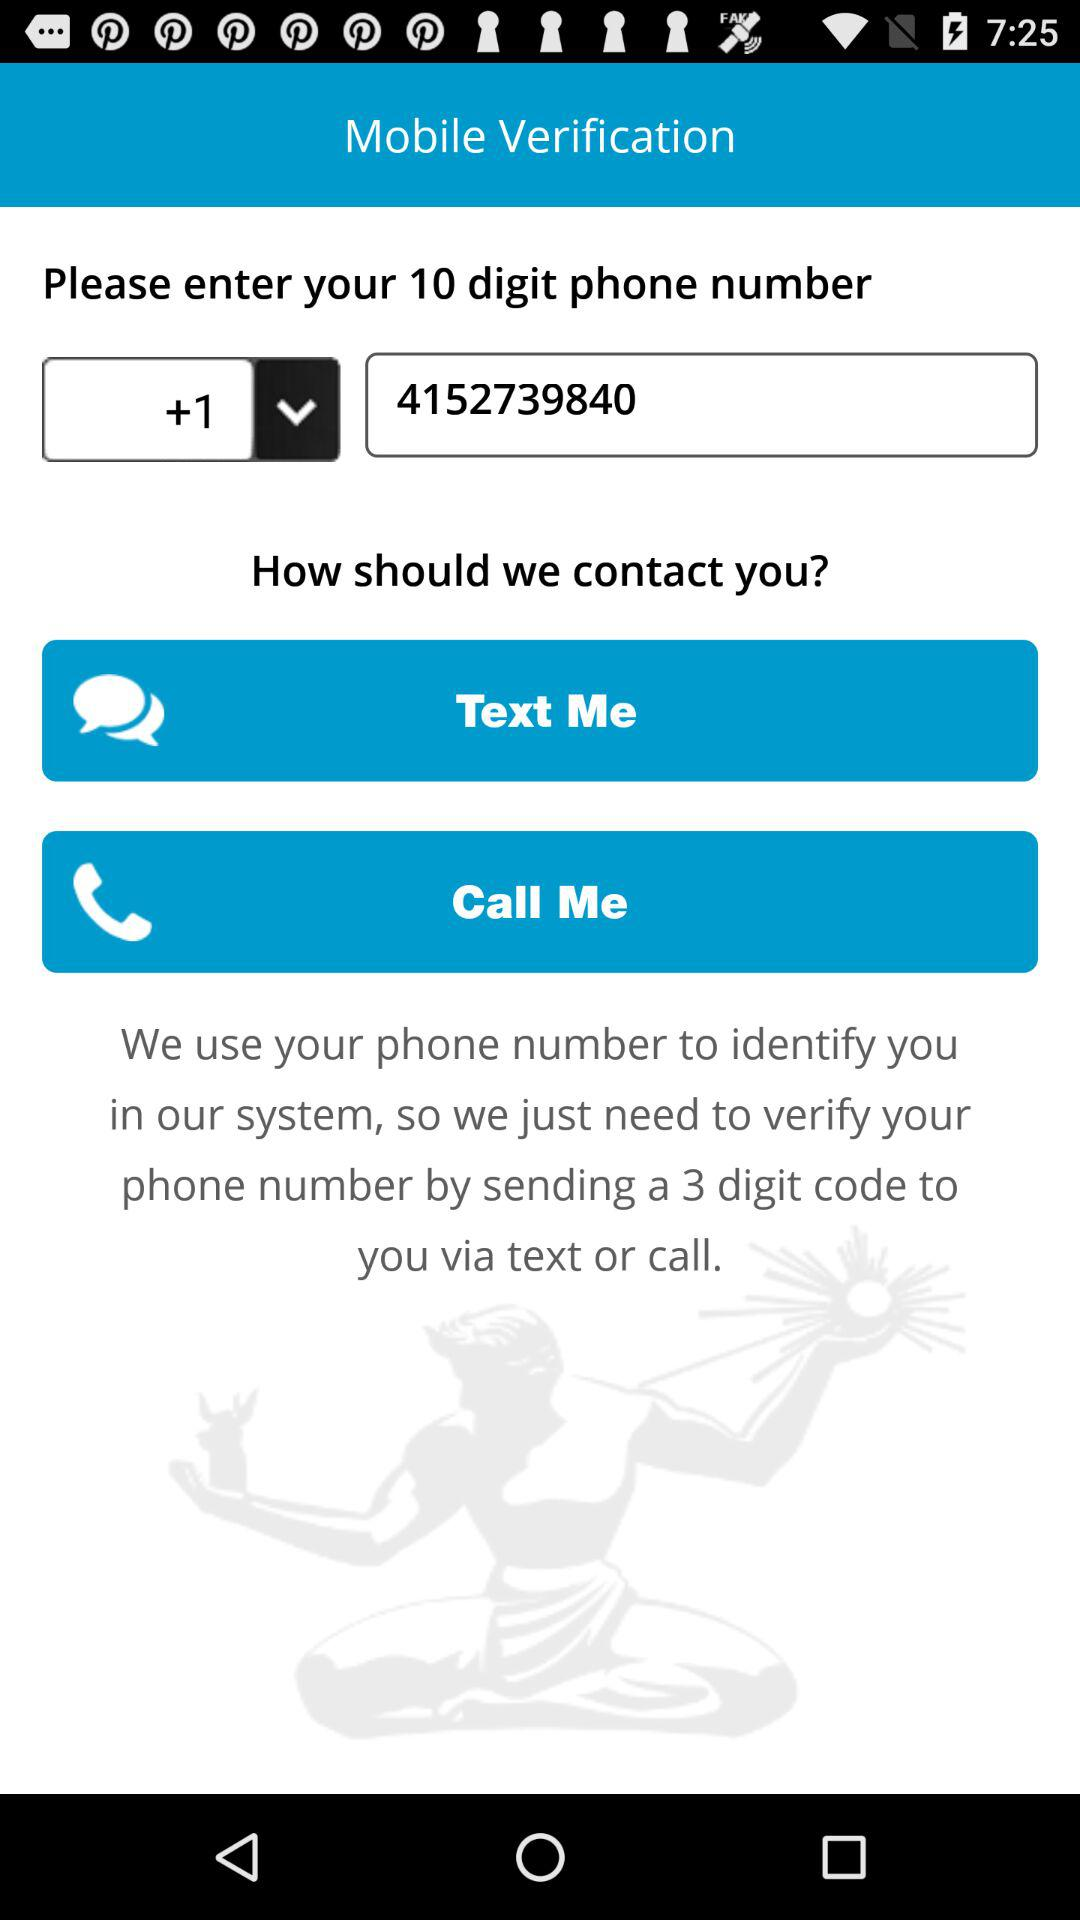What is the entered phone number? The phone number is +1 4152739840. 